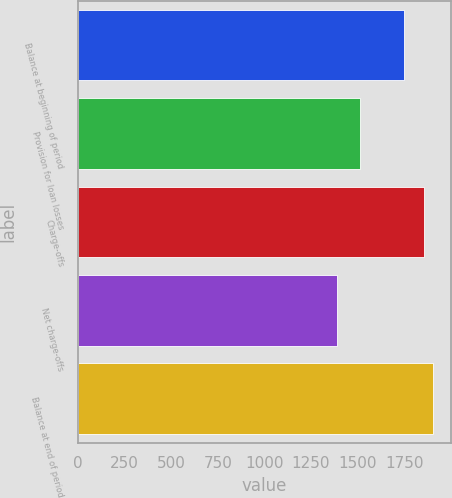Convert chart. <chart><loc_0><loc_0><loc_500><loc_500><bar_chart><fcel>Balance at beginning of period<fcel>Provision for loan losses<fcel>Charge-offs<fcel>Net charge-offs<fcel>Balance at end of period<nl><fcel>1746<fcel>1512<fcel>1855<fcel>1389<fcel>1903<nl></chart> 